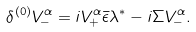Convert formula to latex. <formula><loc_0><loc_0><loc_500><loc_500>\delta ^ { ( 0 ) } V _ { - } ^ { \alpha } = i V _ { + } ^ { \alpha } \bar { \epsilon } \lambda ^ { * } - i \Sigma V _ { - } ^ { \alpha } .</formula> 